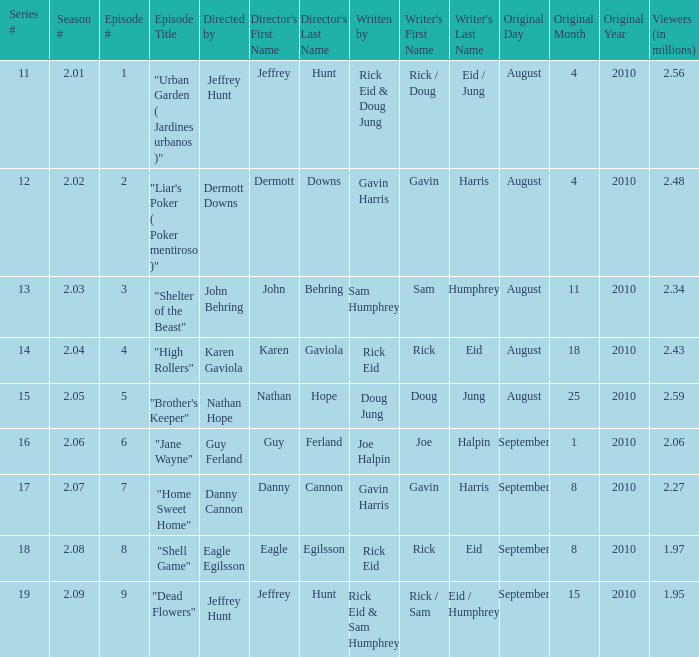If the season number is 2.08, who was the episode written by? Rick Eid. 